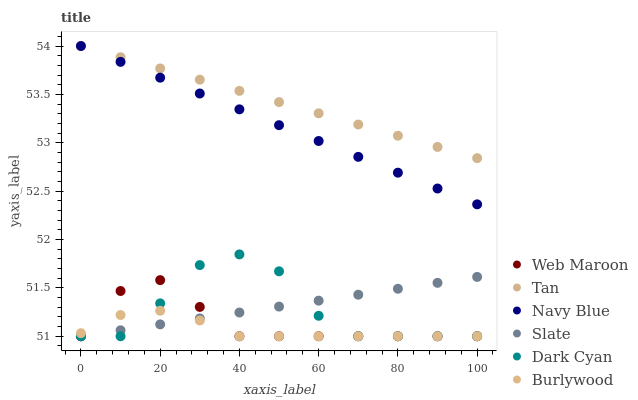Does Burlywood have the minimum area under the curve?
Answer yes or no. Yes. Does Tan have the maximum area under the curve?
Answer yes or no. Yes. Does Navy Blue have the minimum area under the curve?
Answer yes or no. No. Does Navy Blue have the maximum area under the curve?
Answer yes or no. No. Is Slate the smoothest?
Answer yes or no. Yes. Is Dark Cyan the roughest?
Answer yes or no. Yes. Is Navy Blue the smoothest?
Answer yes or no. No. Is Navy Blue the roughest?
Answer yes or no. No. Does Burlywood have the lowest value?
Answer yes or no. Yes. Does Navy Blue have the lowest value?
Answer yes or no. No. Does Tan have the highest value?
Answer yes or no. Yes. Does Slate have the highest value?
Answer yes or no. No. Is Web Maroon less than Navy Blue?
Answer yes or no. Yes. Is Tan greater than Burlywood?
Answer yes or no. Yes. Does Slate intersect Web Maroon?
Answer yes or no. Yes. Is Slate less than Web Maroon?
Answer yes or no. No. Is Slate greater than Web Maroon?
Answer yes or no. No. Does Web Maroon intersect Navy Blue?
Answer yes or no. No. 